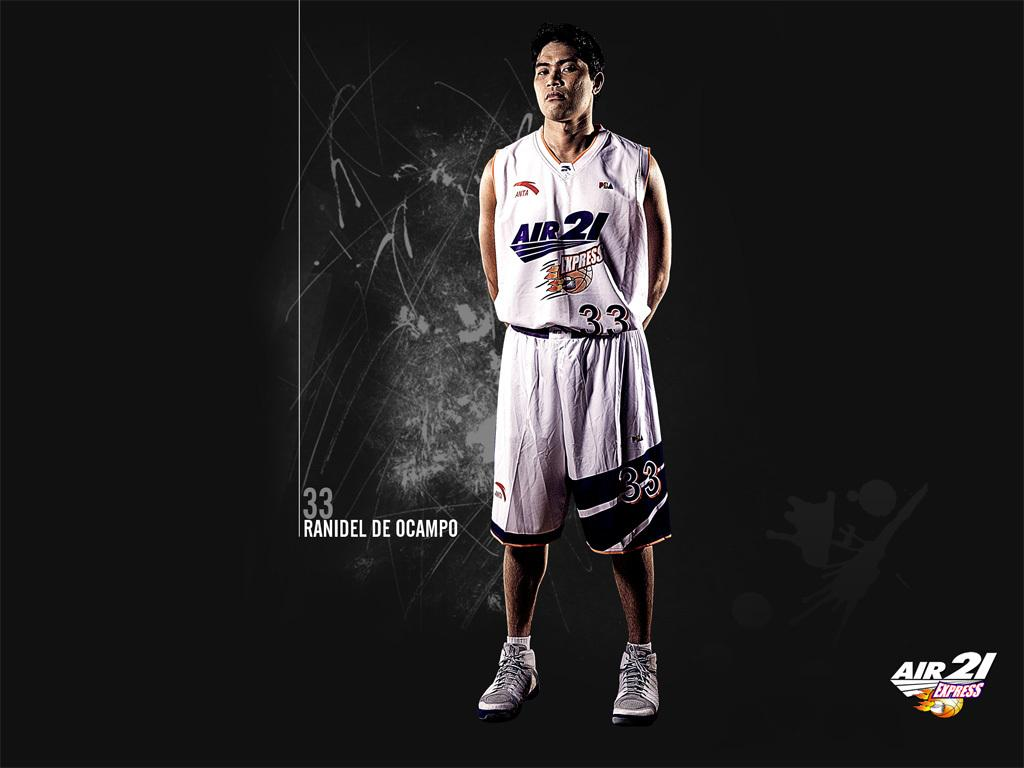What is the overall tone of the image based on the background? The background of the image is dark, which may create a moody or dramatic tone. Can you describe the person in the image? There is a person standing in the image, but no specific details about their appearance or actions are provided. What can be seen on the image that might affect its quality? There are watermarks visible in the image, which may affect its clarity or appearance. What type of division is taking place in the image? There is no division or separation of any kind depicted in the image. Can you tell me where the hospital is located in the image? There is no hospital present in the image. 